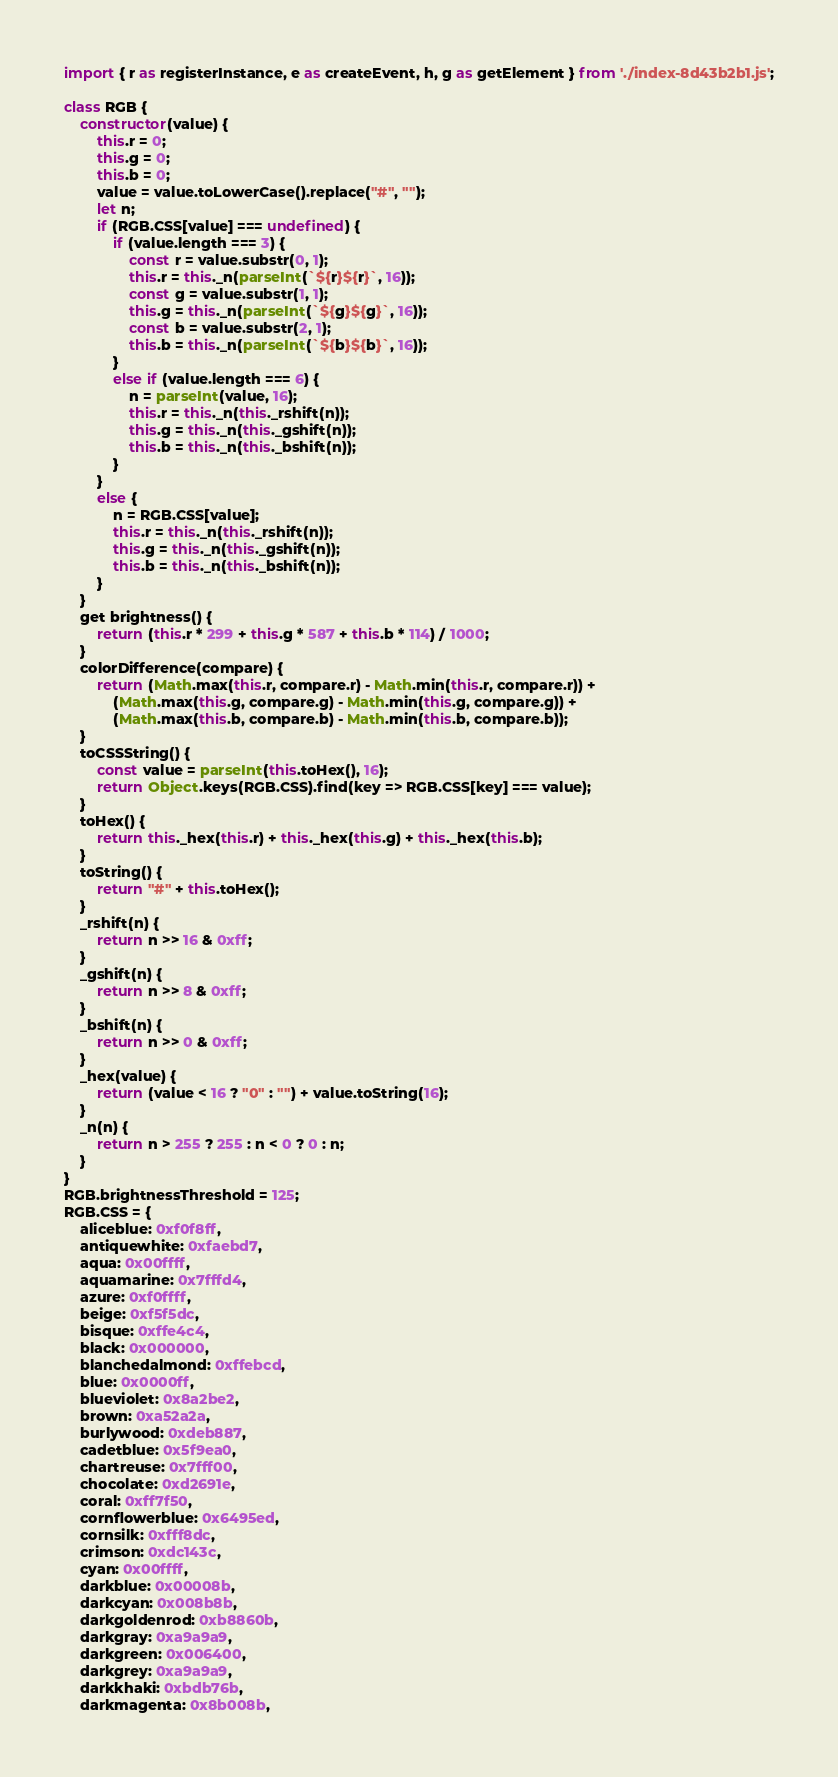<code> <loc_0><loc_0><loc_500><loc_500><_JavaScript_>import { r as registerInstance, e as createEvent, h, g as getElement } from './index-8d43b2b1.js';

class RGB {
    constructor(value) {
        this.r = 0;
        this.g = 0;
        this.b = 0;
        value = value.toLowerCase().replace("#", "");
        let n;
        if (RGB.CSS[value] === undefined) {
            if (value.length === 3) {
                const r = value.substr(0, 1);
                this.r = this._n(parseInt(`${r}${r}`, 16));
                const g = value.substr(1, 1);
                this.g = this._n(parseInt(`${g}${g}`, 16));
                const b = value.substr(2, 1);
                this.b = this._n(parseInt(`${b}${b}`, 16));
            }
            else if (value.length === 6) {
                n = parseInt(value, 16);
                this.r = this._n(this._rshift(n));
                this.g = this._n(this._gshift(n));
                this.b = this._n(this._bshift(n));
            }
        }
        else {
            n = RGB.CSS[value];
            this.r = this._n(this._rshift(n));
            this.g = this._n(this._gshift(n));
            this.b = this._n(this._bshift(n));
        }
    }
    get brightness() {
        return (this.r * 299 + this.g * 587 + this.b * 114) / 1000;
    }
    colorDifference(compare) {
        return (Math.max(this.r, compare.r) - Math.min(this.r, compare.r)) +
            (Math.max(this.g, compare.g) - Math.min(this.g, compare.g)) +
            (Math.max(this.b, compare.b) - Math.min(this.b, compare.b));
    }
    toCSSString() {
        const value = parseInt(this.toHex(), 16);
        return Object.keys(RGB.CSS).find(key => RGB.CSS[key] === value);
    }
    toHex() {
        return this._hex(this.r) + this._hex(this.g) + this._hex(this.b);
    }
    toString() {
        return "#" + this.toHex();
    }
    _rshift(n) {
        return n >> 16 & 0xff;
    }
    _gshift(n) {
        return n >> 8 & 0xff;
    }
    _bshift(n) {
        return n >> 0 & 0xff;
    }
    _hex(value) {
        return (value < 16 ? "0" : "") + value.toString(16);
    }
    _n(n) {
        return n > 255 ? 255 : n < 0 ? 0 : n;
    }
}
RGB.brightnessThreshold = 125;
RGB.CSS = {
    aliceblue: 0xf0f8ff,
    antiquewhite: 0xfaebd7,
    aqua: 0x00ffff,
    aquamarine: 0x7fffd4,
    azure: 0xf0ffff,
    beige: 0xf5f5dc,
    bisque: 0xffe4c4,
    black: 0x000000,
    blanchedalmond: 0xffebcd,
    blue: 0x0000ff,
    blueviolet: 0x8a2be2,
    brown: 0xa52a2a,
    burlywood: 0xdeb887,
    cadetblue: 0x5f9ea0,
    chartreuse: 0x7fff00,
    chocolate: 0xd2691e,
    coral: 0xff7f50,
    cornflowerblue: 0x6495ed,
    cornsilk: 0xfff8dc,
    crimson: 0xdc143c,
    cyan: 0x00ffff,
    darkblue: 0x00008b,
    darkcyan: 0x008b8b,
    darkgoldenrod: 0xb8860b,
    darkgray: 0xa9a9a9,
    darkgreen: 0x006400,
    darkgrey: 0xa9a9a9,
    darkkhaki: 0xbdb76b,
    darkmagenta: 0x8b008b,</code> 